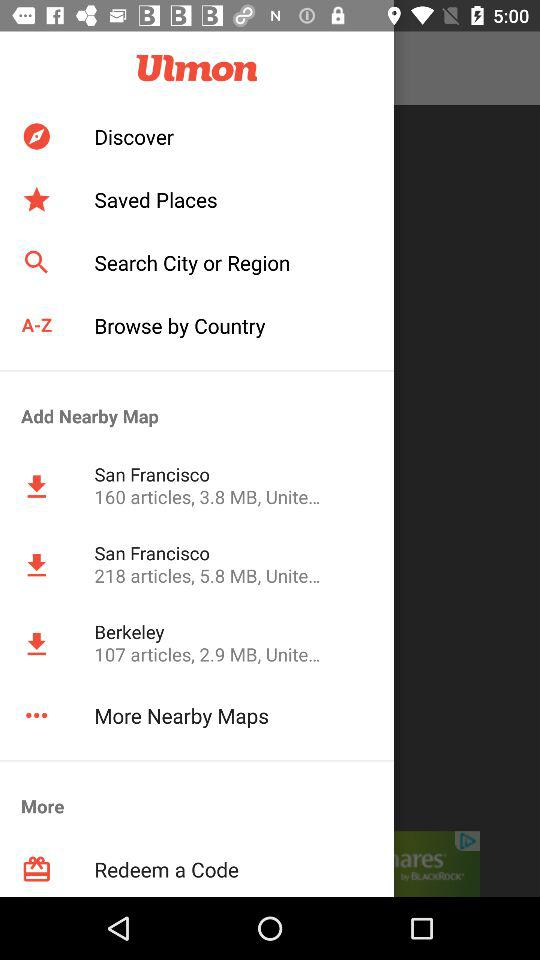What is the size of the articles added to San Francisco, where the number of articles is 160? The size of the articles is 3.8 MB. 